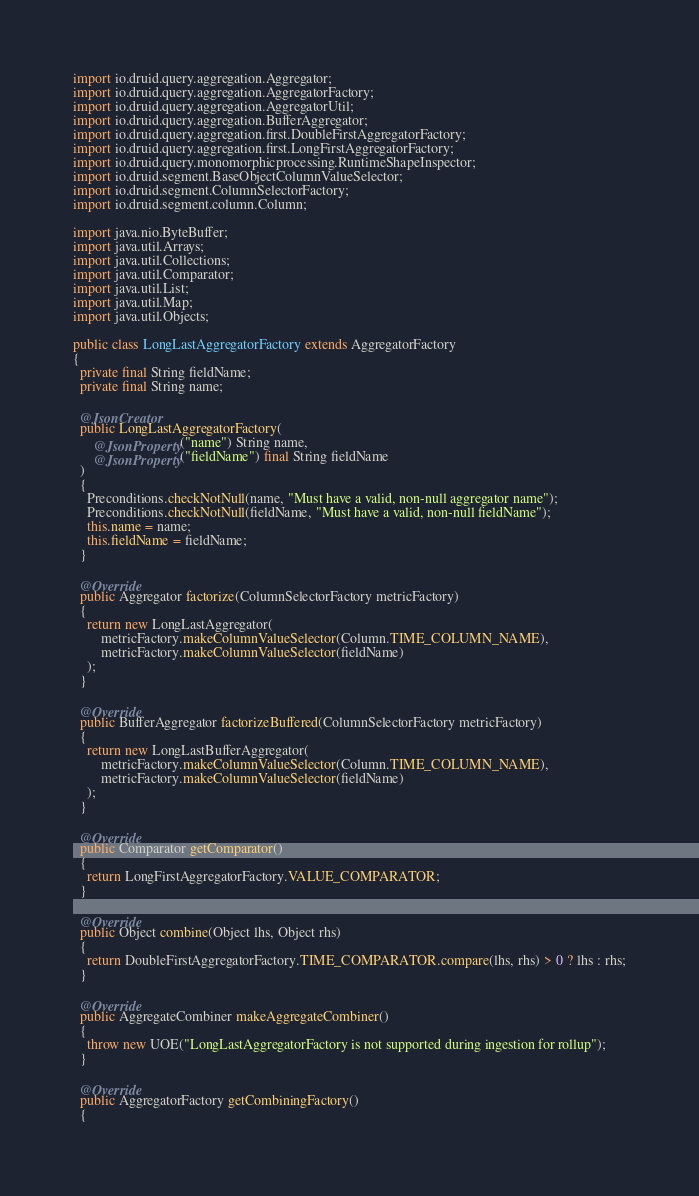Convert code to text. <code><loc_0><loc_0><loc_500><loc_500><_Java_>import io.druid.query.aggregation.Aggregator;
import io.druid.query.aggregation.AggregatorFactory;
import io.druid.query.aggregation.AggregatorUtil;
import io.druid.query.aggregation.BufferAggregator;
import io.druid.query.aggregation.first.DoubleFirstAggregatorFactory;
import io.druid.query.aggregation.first.LongFirstAggregatorFactory;
import io.druid.query.monomorphicprocessing.RuntimeShapeInspector;
import io.druid.segment.BaseObjectColumnValueSelector;
import io.druid.segment.ColumnSelectorFactory;
import io.druid.segment.column.Column;

import java.nio.ByteBuffer;
import java.util.Arrays;
import java.util.Collections;
import java.util.Comparator;
import java.util.List;
import java.util.Map;
import java.util.Objects;

public class LongLastAggregatorFactory extends AggregatorFactory
{
  private final String fieldName;
  private final String name;

  @JsonCreator
  public LongLastAggregatorFactory(
      @JsonProperty("name") String name,
      @JsonProperty("fieldName") final String fieldName
  )
  {
    Preconditions.checkNotNull(name, "Must have a valid, non-null aggregator name");
    Preconditions.checkNotNull(fieldName, "Must have a valid, non-null fieldName");
    this.name = name;
    this.fieldName = fieldName;
  }

  @Override
  public Aggregator factorize(ColumnSelectorFactory metricFactory)
  {
    return new LongLastAggregator(
        metricFactory.makeColumnValueSelector(Column.TIME_COLUMN_NAME),
        metricFactory.makeColumnValueSelector(fieldName)
    );
  }

  @Override
  public BufferAggregator factorizeBuffered(ColumnSelectorFactory metricFactory)
  {
    return new LongLastBufferAggregator(
        metricFactory.makeColumnValueSelector(Column.TIME_COLUMN_NAME),
        metricFactory.makeColumnValueSelector(fieldName)
    );
  }

  @Override
  public Comparator getComparator()
  {
    return LongFirstAggregatorFactory.VALUE_COMPARATOR;
  }

  @Override
  public Object combine(Object lhs, Object rhs)
  {
    return DoubleFirstAggregatorFactory.TIME_COMPARATOR.compare(lhs, rhs) > 0 ? lhs : rhs;
  }

  @Override
  public AggregateCombiner makeAggregateCombiner()
  {
    throw new UOE("LongLastAggregatorFactory is not supported during ingestion for rollup");
  }

  @Override
  public AggregatorFactory getCombiningFactory()
  {</code> 